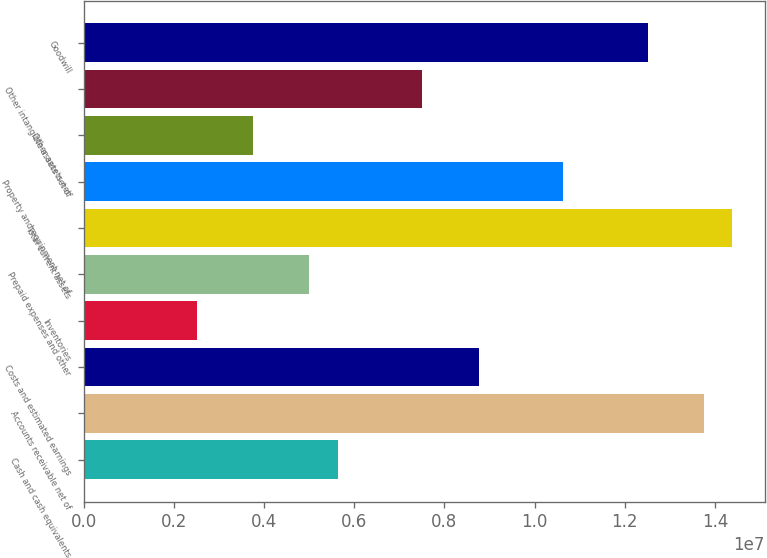Convert chart. <chart><loc_0><loc_0><loc_500><loc_500><bar_chart><fcel>Cash and cash equivalents<fcel>Accounts receivable net of<fcel>Costs and estimated earnings<fcel>Inventories<fcel>Prepaid expenses and other<fcel>Total current assets<fcel>Property and equipment net of<fcel>Other assets net<fcel>Other intangible assets net of<fcel>Goodwill<nl><fcel>5.62822e+06<fcel>1.37579e+07<fcel>8.75502e+06<fcel>2.50143e+06<fcel>5.00287e+06<fcel>1.43832e+07<fcel>1.06311e+07<fcel>3.75215e+06<fcel>7.5043e+06<fcel>1.25072e+07<nl></chart> 